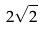<formula> <loc_0><loc_0><loc_500><loc_500>2 \sqrt { 2 }</formula> 